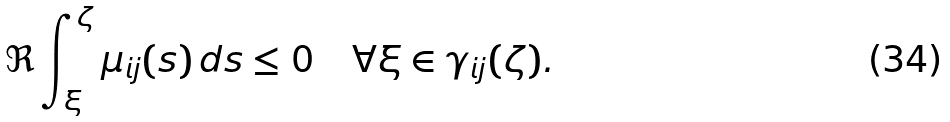Convert formula to latex. <formula><loc_0><loc_0><loc_500><loc_500>\Re \int _ { \xi } ^ { \zeta } \mu _ { i j } ( s ) \, d s \leq 0 \quad \forall \xi \in \gamma _ { i j } ( \zeta ) .</formula> 